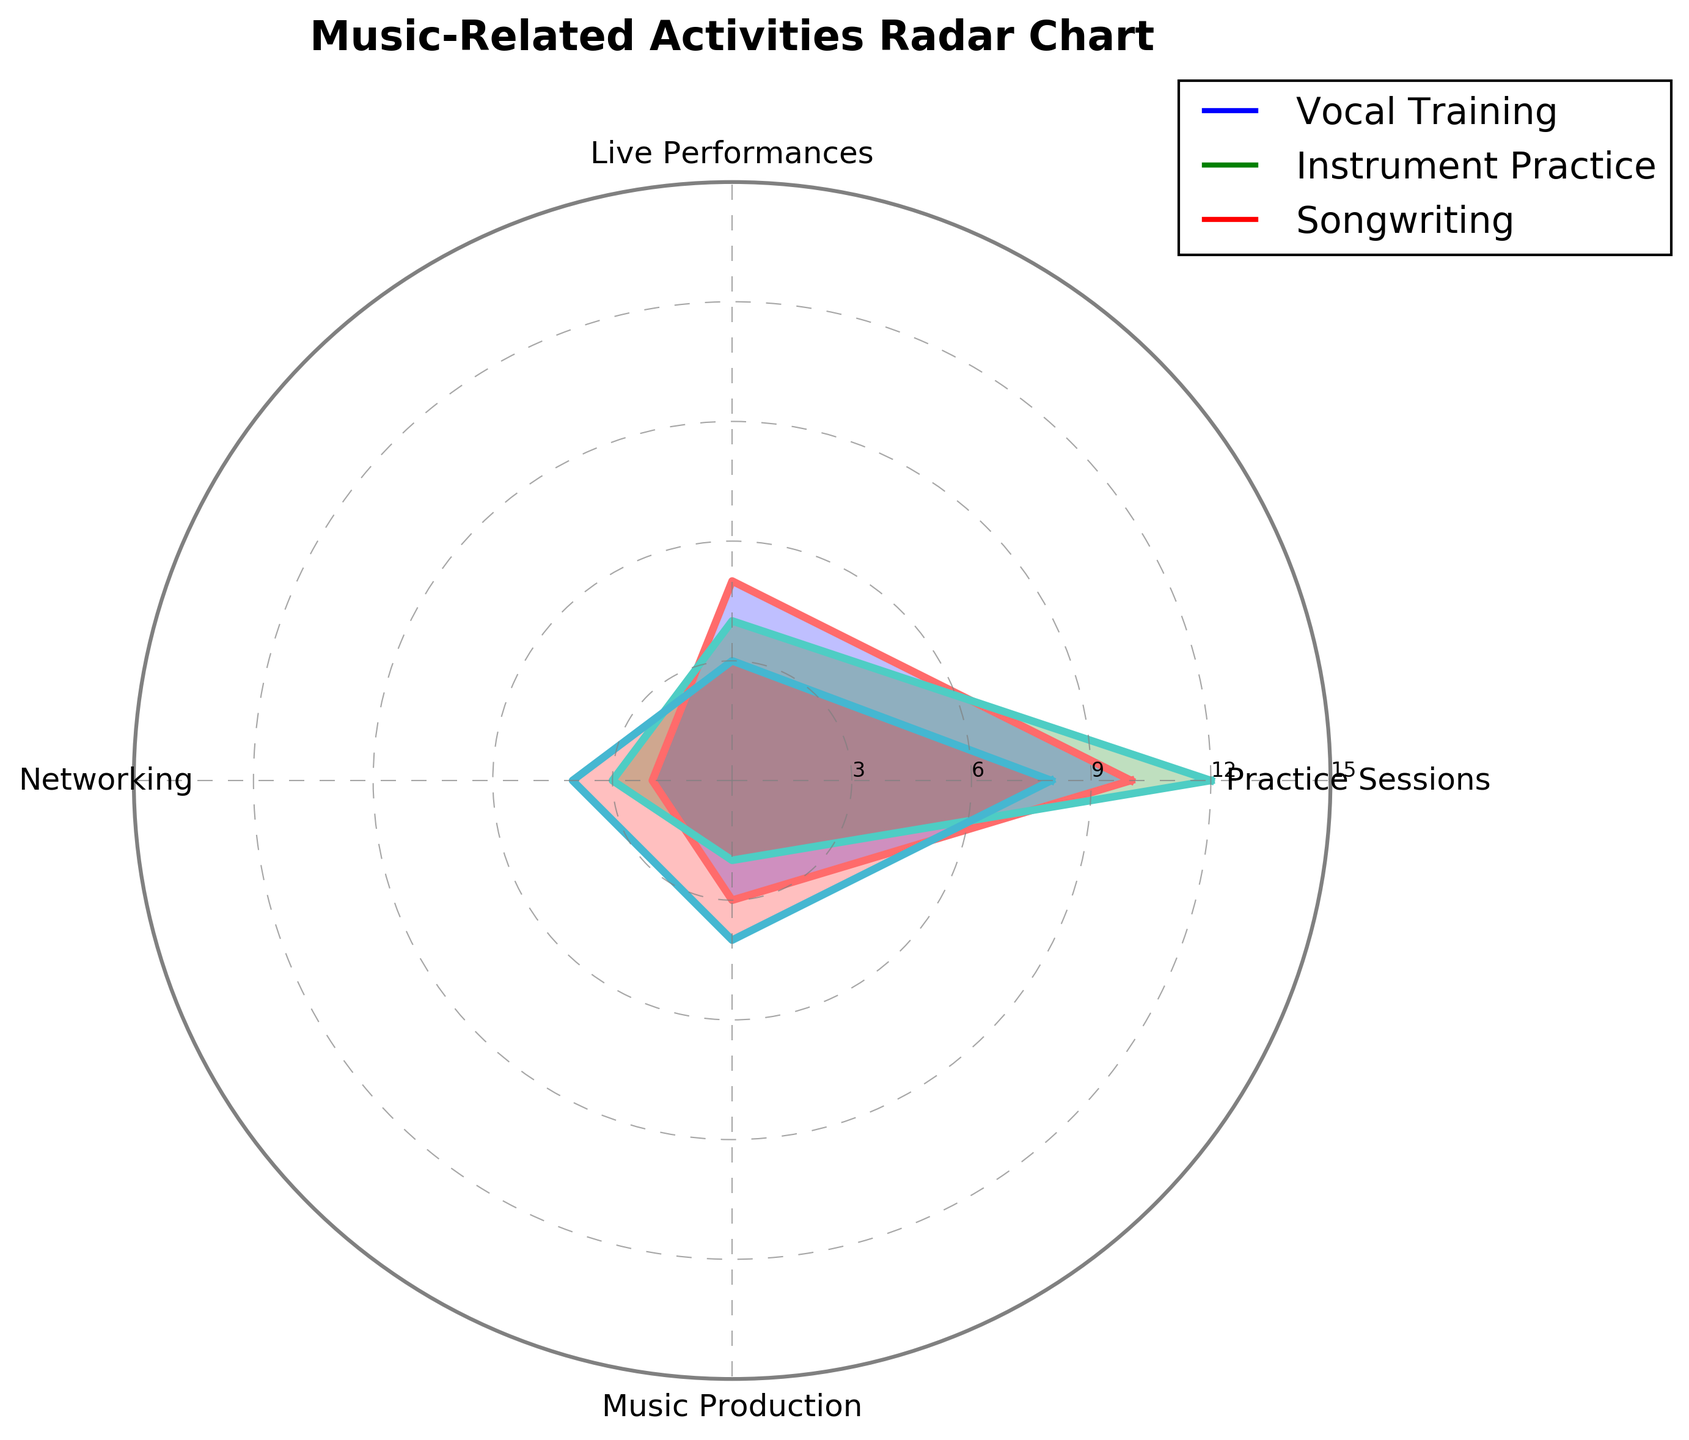How many activities are being compared in the radar chart? There are three activities being compared in the radar chart: Vocal Training, Instrument Practice, and Songwriting. This is indicated by the plot labels.
Answer: 3 What is the title of the radar chart? The title of the radar chart is displayed at the top of the figure. It reads "Music-Related Activities Radar Chart."
Answer: Music-Related Activities Radar Chart Which activity has the highest value in Live Performances? By looking at the Live Performances category on the radar chart, we see that Instrument Practice has the highest value.
Answer: Instrument Practice How many values fall within the range of 3 to 6 for each category for Vocal Training? For Vocal Training, the values within the range of 3 to 6 are: Live Performances (5) and Recording Sessions (3). Total count is 2.
Answer: 2 Between Songwriting and Social Media Engagement, which one has higher values overall? To compare, we need to look at the values for each category. For Songwriting, the values are (8, 3, 4, 4), and for Social Media Engagement, the values are (5, 1, 8, 7). Summing up the values: Songwriting = 8+3+4+4 = 19, Social Media Engagement = 5+1+8+7 = 21. Therefore, Social Media Engagement has higher overall values.
Answer: Social Media Engagement On average, how much time does Songwriting spend on music-related activities? To find the average, sum the values for Songwriting (8 + 3 + 4 + 4 = 19) and then divide by the number of categories (5). The average is 19 / 5 = 3.8.
Answer: 3.8 If one wanted to focus on the most neglected activity, which one would it be for Vocal Training in Networking? Look at the Networking category for Vocal Training, which has the value 2. Compare this value with other categories to see that Networking is indeed the least time-invested activity for Vocal Training.
Answer: Networking In which category are Vocal Training and Instrument Practice values the closest? To determine the closest values, we compare the difference in each category: Practice Sessions (2), Live Performances (1), Networking (1), Music Production (1). The smallest differences are in Live Performances (1), Networking (1), and Music Production (1).
Answer: Live Performances / Networking / Music Production What are the range and the peak values of Instrument Practice in Practice Sessions? The value for Instrument Practice in Practice Sessions is clearly marked, showing the value as 12.
Answer: 12 Which category has the most significant variation among the activities shown? By observing the spread in each category: Practice Sessions (5 to 12), Live Performances (1 to 7), Networking (2 to 8), Music Production (2 to 7), we see the greatest variation in Practice Sessions (12-5=7).
Answer: Practice Sessions 